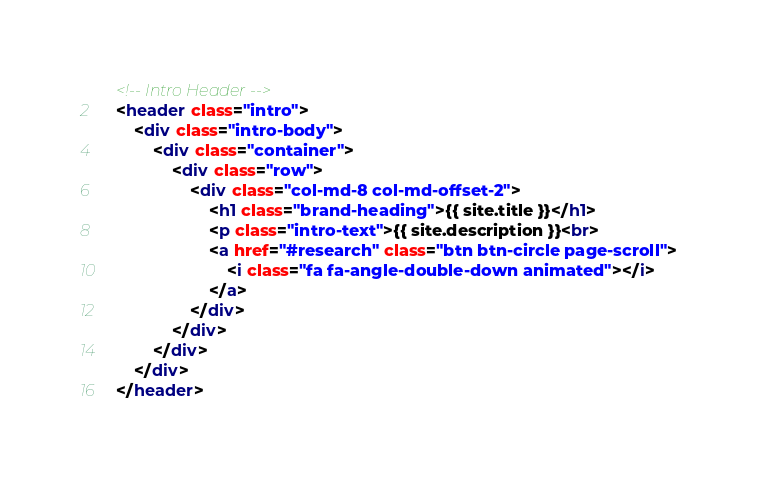Convert code to text. <code><loc_0><loc_0><loc_500><loc_500><_HTML_>    <!-- Intro Header -->
    <header class="intro">
        <div class="intro-body">
            <div class="container">
                <div class="row">
                    <div class="col-md-8 col-md-offset-2">
                        <h1 class="brand-heading">{{ site.title }}</h1>
                        <p class="intro-text">{{ site.description }}<br>
                        <a href="#research" class="btn btn-circle page-scroll">
                            <i class="fa fa-angle-double-down animated"></i>
                        </a>
                    </div>
                </div>
            </div>
        </div>
    </header>
</code> 